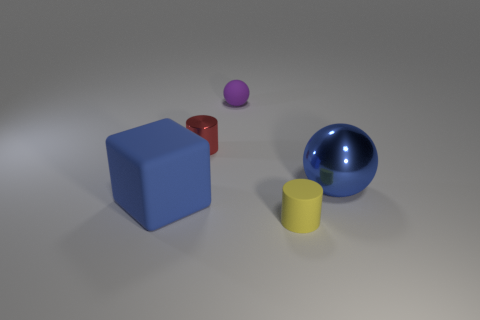The block that is the same color as the big ball is what size?
Provide a short and direct response. Large. There is a metallic thing that is left of the sphere on the left side of the big blue object that is on the right side of the tiny purple object; what is its shape?
Your answer should be very brief. Cylinder. What number of other objects are the same material as the big blue sphere?
Ensure brevity in your answer.  1. Are the large blue thing left of the big blue metallic sphere and the small object in front of the big blue block made of the same material?
Your response must be concise. Yes. How many things are in front of the big blue ball and on the left side of the yellow thing?
Your response must be concise. 1. Are there any small blue things that have the same shape as the small yellow rubber object?
Give a very brief answer. No. The blue metal thing that is the same size as the matte cube is what shape?
Make the answer very short. Sphere. Is the number of rubber balls in front of the rubber ball the same as the number of small red shiny objects in front of the tiny metallic cylinder?
Offer a terse response. Yes. What is the size of the purple matte ball that is on the right side of the big blue thing that is in front of the big ball?
Your answer should be compact. Small. Are there any matte balls that have the same size as the red object?
Keep it short and to the point. Yes. 